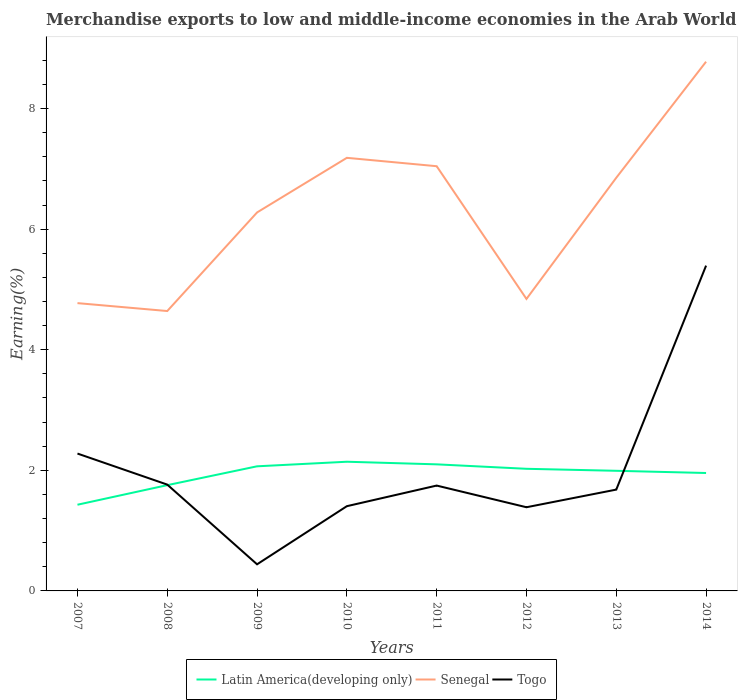Is the number of lines equal to the number of legend labels?
Provide a short and direct response. Yes. Across all years, what is the maximum percentage of amount earned from merchandise exports in Latin America(developing only)?
Offer a very short reply. 1.43. What is the total percentage of amount earned from merchandise exports in Latin America(developing only) in the graph?
Offer a very short reply. -0.39. What is the difference between the highest and the second highest percentage of amount earned from merchandise exports in Senegal?
Make the answer very short. 4.14. Is the percentage of amount earned from merchandise exports in Togo strictly greater than the percentage of amount earned from merchandise exports in Senegal over the years?
Provide a short and direct response. Yes. How many years are there in the graph?
Your answer should be compact. 8. Does the graph contain any zero values?
Your answer should be compact. No. What is the title of the graph?
Make the answer very short. Merchandise exports to low and middle-income economies in the Arab World. What is the label or title of the Y-axis?
Provide a succinct answer. Earning(%). What is the Earning(%) of Latin America(developing only) in 2007?
Offer a terse response. 1.43. What is the Earning(%) of Senegal in 2007?
Your answer should be very brief. 4.77. What is the Earning(%) of Togo in 2007?
Give a very brief answer. 2.28. What is the Earning(%) in Latin America(developing only) in 2008?
Provide a succinct answer. 1.75. What is the Earning(%) of Senegal in 2008?
Ensure brevity in your answer.  4.64. What is the Earning(%) of Togo in 2008?
Provide a succinct answer. 1.76. What is the Earning(%) of Latin America(developing only) in 2009?
Give a very brief answer. 2.07. What is the Earning(%) in Senegal in 2009?
Your response must be concise. 6.28. What is the Earning(%) of Togo in 2009?
Provide a short and direct response. 0.44. What is the Earning(%) in Latin America(developing only) in 2010?
Your response must be concise. 2.14. What is the Earning(%) in Senegal in 2010?
Offer a terse response. 7.18. What is the Earning(%) of Togo in 2010?
Your answer should be compact. 1.41. What is the Earning(%) in Latin America(developing only) in 2011?
Your response must be concise. 2.1. What is the Earning(%) in Senegal in 2011?
Your answer should be compact. 7.04. What is the Earning(%) in Togo in 2011?
Your response must be concise. 1.75. What is the Earning(%) in Latin America(developing only) in 2012?
Your response must be concise. 2.03. What is the Earning(%) of Senegal in 2012?
Your answer should be compact. 4.84. What is the Earning(%) in Togo in 2012?
Your response must be concise. 1.39. What is the Earning(%) of Latin America(developing only) in 2013?
Your answer should be compact. 1.99. What is the Earning(%) in Senegal in 2013?
Provide a succinct answer. 6.85. What is the Earning(%) of Togo in 2013?
Provide a short and direct response. 1.68. What is the Earning(%) in Latin America(developing only) in 2014?
Your response must be concise. 1.96. What is the Earning(%) in Senegal in 2014?
Offer a very short reply. 8.78. What is the Earning(%) of Togo in 2014?
Offer a terse response. 5.4. Across all years, what is the maximum Earning(%) of Latin America(developing only)?
Your response must be concise. 2.14. Across all years, what is the maximum Earning(%) in Senegal?
Your response must be concise. 8.78. Across all years, what is the maximum Earning(%) in Togo?
Your answer should be compact. 5.4. Across all years, what is the minimum Earning(%) of Latin America(developing only)?
Make the answer very short. 1.43. Across all years, what is the minimum Earning(%) in Senegal?
Provide a succinct answer. 4.64. Across all years, what is the minimum Earning(%) in Togo?
Provide a succinct answer. 0.44. What is the total Earning(%) of Latin America(developing only) in the graph?
Your answer should be very brief. 15.47. What is the total Earning(%) of Senegal in the graph?
Offer a terse response. 50.39. What is the total Earning(%) of Togo in the graph?
Make the answer very short. 16.1. What is the difference between the Earning(%) in Latin America(developing only) in 2007 and that in 2008?
Keep it short and to the point. -0.32. What is the difference between the Earning(%) in Senegal in 2007 and that in 2008?
Keep it short and to the point. 0.13. What is the difference between the Earning(%) of Togo in 2007 and that in 2008?
Your response must be concise. 0.51. What is the difference between the Earning(%) in Latin America(developing only) in 2007 and that in 2009?
Make the answer very short. -0.64. What is the difference between the Earning(%) of Senegal in 2007 and that in 2009?
Keep it short and to the point. -1.5. What is the difference between the Earning(%) in Togo in 2007 and that in 2009?
Your response must be concise. 1.84. What is the difference between the Earning(%) in Latin America(developing only) in 2007 and that in 2010?
Provide a succinct answer. -0.71. What is the difference between the Earning(%) of Senegal in 2007 and that in 2010?
Offer a terse response. -2.41. What is the difference between the Earning(%) of Togo in 2007 and that in 2010?
Keep it short and to the point. 0.87. What is the difference between the Earning(%) of Latin America(developing only) in 2007 and that in 2011?
Provide a succinct answer. -0.67. What is the difference between the Earning(%) of Senegal in 2007 and that in 2011?
Keep it short and to the point. -2.27. What is the difference between the Earning(%) of Togo in 2007 and that in 2011?
Your response must be concise. 0.53. What is the difference between the Earning(%) in Latin America(developing only) in 2007 and that in 2012?
Offer a terse response. -0.6. What is the difference between the Earning(%) in Senegal in 2007 and that in 2012?
Keep it short and to the point. -0.07. What is the difference between the Earning(%) of Togo in 2007 and that in 2012?
Provide a short and direct response. 0.89. What is the difference between the Earning(%) in Latin America(developing only) in 2007 and that in 2013?
Give a very brief answer. -0.56. What is the difference between the Earning(%) in Senegal in 2007 and that in 2013?
Your answer should be very brief. -2.08. What is the difference between the Earning(%) in Togo in 2007 and that in 2013?
Your response must be concise. 0.6. What is the difference between the Earning(%) of Latin America(developing only) in 2007 and that in 2014?
Your answer should be very brief. -0.53. What is the difference between the Earning(%) in Senegal in 2007 and that in 2014?
Provide a short and direct response. -4. What is the difference between the Earning(%) of Togo in 2007 and that in 2014?
Your response must be concise. -3.12. What is the difference between the Earning(%) of Latin America(developing only) in 2008 and that in 2009?
Offer a terse response. -0.31. What is the difference between the Earning(%) in Senegal in 2008 and that in 2009?
Ensure brevity in your answer.  -1.64. What is the difference between the Earning(%) of Togo in 2008 and that in 2009?
Your response must be concise. 1.32. What is the difference between the Earning(%) in Latin America(developing only) in 2008 and that in 2010?
Offer a terse response. -0.39. What is the difference between the Earning(%) in Senegal in 2008 and that in 2010?
Make the answer very short. -2.54. What is the difference between the Earning(%) of Togo in 2008 and that in 2010?
Your response must be concise. 0.36. What is the difference between the Earning(%) in Latin America(developing only) in 2008 and that in 2011?
Give a very brief answer. -0.34. What is the difference between the Earning(%) in Senegal in 2008 and that in 2011?
Your answer should be compact. -2.4. What is the difference between the Earning(%) in Togo in 2008 and that in 2011?
Make the answer very short. 0.02. What is the difference between the Earning(%) of Latin America(developing only) in 2008 and that in 2012?
Your answer should be very brief. -0.27. What is the difference between the Earning(%) of Senegal in 2008 and that in 2012?
Make the answer very short. -0.2. What is the difference between the Earning(%) in Togo in 2008 and that in 2012?
Offer a terse response. 0.38. What is the difference between the Earning(%) in Latin America(developing only) in 2008 and that in 2013?
Provide a succinct answer. -0.24. What is the difference between the Earning(%) in Senegal in 2008 and that in 2013?
Offer a very short reply. -2.21. What is the difference between the Earning(%) of Togo in 2008 and that in 2013?
Provide a short and direct response. 0.08. What is the difference between the Earning(%) of Latin America(developing only) in 2008 and that in 2014?
Keep it short and to the point. -0.2. What is the difference between the Earning(%) in Senegal in 2008 and that in 2014?
Provide a short and direct response. -4.14. What is the difference between the Earning(%) in Togo in 2008 and that in 2014?
Offer a very short reply. -3.63. What is the difference between the Earning(%) of Latin America(developing only) in 2009 and that in 2010?
Your answer should be compact. -0.08. What is the difference between the Earning(%) of Senegal in 2009 and that in 2010?
Provide a short and direct response. -0.91. What is the difference between the Earning(%) of Togo in 2009 and that in 2010?
Your answer should be compact. -0.96. What is the difference between the Earning(%) in Latin America(developing only) in 2009 and that in 2011?
Give a very brief answer. -0.03. What is the difference between the Earning(%) of Senegal in 2009 and that in 2011?
Give a very brief answer. -0.77. What is the difference between the Earning(%) of Togo in 2009 and that in 2011?
Offer a very short reply. -1.31. What is the difference between the Earning(%) of Latin America(developing only) in 2009 and that in 2012?
Your answer should be compact. 0.04. What is the difference between the Earning(%) of Senegal in 2009 and that in 2012?
Offer a very short reply. 1.43. What is the difference between the Earning(%) of Togo in 2009 and that in 2012?
Your answer should be compact. -0.95. What is the difference between the Earning(%) of Latin America(developing only) in 2009 and that in 2013?
Your answer should be very brief. 0.07. What is the difference between the Earning(%) of Senegal in 2009 and that in 2013?
Offer a very short reply. -0.58. What is the difference between the Earning(%) in Togo in 2009 and that in 2013?
Offer a terse response. -1.24. What is the difference between the Earning(%) of Latin America(developing only) in 2009 and that in 2014?
Ensure brevity in your answer.  0.11. What is the difference between the Earning(%) of Senegal in 2009 and that in 2014?
Keep it short and to the point. -2.5. What is the difference between the Earning(%) in Togo in 2009 and that in 2014?
Provide a short and direct response. -4.95. What is the difference between the Earning(%) of Latin America(developing only) in 2010 and that in 2011?
Keep it short and to the point. 0.04. What is the difference between the Earning(%) in Senegal in 2010 and that in 2011?
Ensure brevity in your answer.  0.14. What is the difference between the Earning(%) in Togo in 2010 and that in 2011?
Your answer should be very brief. -0.34. What is the difference between the Earning(%) of Latin America(developing only) in 2010 and that in 2012?
Keep it short and to the point. 0.12. What is the difference between the Earning(%) in Senegal in 2010 and that in 2012?
Provide a short and direct response. 2.34. What is the difference between the Earning(%) in Togo in 2010 and that in 2012?
Give a very brief answer. 0.02. What is the difference between the Earning(%) of Latin America(developing only) in 2010 and that in 2013?
Offer a very short reply. 0.15. What is the difference between the Earning(%) in Senegal in 2010 and that in 2013?
Give a very brief answer. 0.33. What is the difference between the Earning(%) of Togo in 2010 and that in 2013?
Keep it short and to the point. -0.27. What is the difference between the Earning(%) of Latin America(developing only) in 2010 and that in 2014?
Ensure brevity in your answer.  0.19. What is the difference between the Earning(%) in Senegal in 2010 and that in 2014?
Provide a short and direct response. -1.59. What is the difference between the Earning(%) in Togo in 2010 and that in 2014?
Keep it short and to the point. -3.99. What is the difference between the Earning(%) in Latin America(developing only) in 2011 and that in 2012?
Your answer should be compact. 0.07. What is the difference between the Earning(%) in Senegal in 2011 and that in 2012?
Provide a succinct answer. 2.2. What is the difference between the Earning(%) in Togo in 2011 and that in 2012?
Ensure brevity in your answer.  0.36. What is the difference between the Earning(%) in Latin America(developing only) in 2011 and that in 2013?
Provide a short and direct response. 0.11. What is the difference between the Earning(%) of Senegal in 2011 and that in 2013?
Your answer should be compact. 0.19. What is the difference between the Earning(%) of Togo in 2011 and that in 2013?
Offer a very short reply. 0.07. What is the difference between the Earning(%) in Latin America(developing only) in 2011 and that in 2014?
Your response must be concise. 0.14. What is the difference between the Earning(%) of Senegal in 2011 and that in 2014?
Offer a very short reply. -1.73. What is the difference between the Earning(%) of Togo in 2011 and that in 2014?
Keep it short and to the point. -3.65. What is the difference between the Earning(%) in Latin America(developing only) in 2012 and that in 2013?
Your response must be concise. 0.03. What is the difference between the Earning(%) in Senegal in 2012 and that in 2013?
Your response must be concise. -2.01. What is the difference between the Earning(%) in Togo in 2012 and that in 2013?
Offer a very short reply. -0.29. What is the difference between the Earning(%) in Latin America(developing only) in 2012 and that in 2014?
Provide a succinct answer. 0.07. What is the difference between the Earning(%) of Senegal in 2012 and that in 2014?
Your answer should be compact. -3.93. What is the difference between the Earning(%) in Togo in 2012 and that in 2014?
Offer a terse response. -4.01. What is the difference between the Earning(%) in Latin America(developing only) in 2013 and that in 2014?
Provide a succinct answer. 0.04. What is the difference between the Earning(%) in Senegal in 2013 and that in 2014?
Ensure brevity in your answer.  -1.92. What is the difference between the Earning(%) of Togo in 2013 and that in 2014?
Offer a terse response. -3.71. What is the difference between the Earning(%) in Latin America(developing only) in 2007 and the Earning(%) in Senegal in 2008?
Offer a very short reply. -3.21. What is the difference between the Earning(%) of Latin America(developing only) in 2007 and the Earning(%) of Togo in 2008?
Keep it short and to the point. -0.33. What is the difference between the Earning(%) of Senegal in 2007 and the Earning(%) of Togo in 2008?
Offer a very short reply. 3.01. What is the difference between the Earning(%) in Latin America(developing only) in 2007 and the Earning(%) in Senegal in 2009?
Your answer should be compact. -4.85. What is the difference between the Earning(%) of Latin America(developing only) in 2007 and the Earning(%) of Togo in 2009?
Your answer should be compact. 0.99. What is the difference between the Earning(%) in Senegal in 2007 and the Earning(%) in Togo in 2009?
Ensure brevity in your answer.  4.33. What is the difference between the Earning(%) of Latin America(developing only) in 2007 and the Earning(%) of Senegal in 2010?
Provide a short and direct response. -5.75. What is the difference between the Earning(%) of Latin America(developing only) in 2007 and the Earning(%) of Togo in 2010?
Offer a very short reply. 0.02. What is the difference between the Earning(%) in Senegal in 2007 and the Earning(%) in Togo in 2010?
Your response must be concise. 3.37. What is the difference between the Earning(%) in Latin America(developing only) in 2007 and the Earning(%) in Senegal in 2011?
Offer a terse response. -5.61. What is the difference between the Earning(%) in Latin America(developing only) in 2007 and the Earning(%) in Togo in 2011?
Your answer should be compact. -0.32. What is the difference between the Earning(%) in Senegal in 2007 and the Earning(%) in Togo in 2011?
Your answer should be compact. 3.03. What is the difference between the Earning(%) in Latin America(developing only) in 2007 and the Earning(%) in Senegal in 2012?
Offer a very short reply. -3.41. What is the difference between the Earning(%) in Latin America(developing only) in 2007 and the Earning(%) in Togo in 2012?
Offer a very short reply. 0.04. What is the difference between the Earning(%) in Senegal in 2007 and the Earning(%) in Togo in 2012?
Offer a terse response. 3.39. What is the difference between the Earning(%) of Latin America(developing only) in 2007 and the Earning(%) of Senegal in 2013?
Give a very brief answer. -5.42. What is the difference between the Earning(%) in Latin America(developing only) in 2007 and the Earning(%) in Togo in 2013?
Offer a very short reply. -0.25. What is the difference between the Earning(%) of Senegal in 2007 and the Earning(%) of Togo in 2013?
Ensure brevity in your answer.  3.09. What is the difference between the Earning(%) of Latin America(developing only) in 2007 and the Earning(%) of Senegal in 2014?
Ensure brevity in your answer.  -7.35. What is the difference between the Earning(%) in Latin America(developing only) in 2007 and the Earning(%) in Togo in 2014?
Give a very brief answer. -3.97. What is the difference between the Earning(%) in Senegal in 2007 and the Earning(%) in Togo in 2014?
Make the answer very short. -0.62. What is the difference between the Earning(%) in Latin America(developing only) in 2008 and the Earning(%) in Senegal in 2009?
Offer a terse response. -4.52. What is the difference between the Earning(%) in Latin America(developing only) in 2008 and the Earning(%) in Togo in 2009?
Your response must be concise. 1.31. What is the difference between the Earning(%) of Senegal in 2008 and the Earning(%) of Togo in 2009?
Keep it short and to the point. 4.2. What is the difference between the Earning(%) in Latin America(developing only) in 2008 and the Earning(%) in Senegal in 2010?
Your answer should be very brief. -5.43. What is the difference between the Earning(%) of Latin America(developing only) in 2008 and the Earning(%) of Togo in 2010?
Your response must be concise. 0.35. What is the difference between the Earning(%) of Senegal in 2008 and the Earning(%) of Togo in 2010?
Your answer should be compact. 3.24. What is the difference between the Earning(%) in Latin America(developing only) in 2008 and the Earning(%) in Senegal in 2011?
Your answer should be compact. -5.29. What is the difference between the Earning(%) of Latin America(developing only) in 2008 and the Earning(%) of Togo in 2011?
Provide a short and direct response. 0.01. What is the difference between the Earning(%) in Senegal in 2008 and the Earning(%) in Togo in 2011?
Your answer should be compact. 2.89. What is the difference between the Earning(%) of Latin America(developing only) in 2008 and the Earning(%) of Senegal in 2012?
Your answer should be very brief. -3.09. What is the difference between the Earning(%) in Latin America(developing only) in 2008 and the Earning(%) in Togo in 2012?
Offer a terse response. 0.37. What is the difference between the Earning(%) in Senegal in 2008 and the Earning(%) in Togo in 2012?
Ensure brevity in your answer.  3.25. What is the difference between the Earning(%) of Latin America(developing only) in 2008 and the Earning(%) of Senegal in 2013?
Provide a succinct answer. -5.1. What is the difference between the Earning(%) of Latin America(developing only) in 2008 and the Earning(%) of Togo in 2013?
Your answer should be very brief. 0.07. What is the difference between the Earning(%) in Senegal in 2008 and the Earning(%) in Togo in 2013?
Your answer should be compact. 2.96. What is the difference between the Earning(%) of Latin America(developing only) in 2008 and the Earning(%) of Senegal in 2014?
Offer a very short reply. -7.02. What is the difference between the Earning(%) in Latin America(developing only) in 2008 and the Earning(%) in Togo in 2014?
Offer a very short reply. -3.64. What is the difference between the Earning(%) of Senegal in 2008 and the Earning(%) of Togo in 2014?
Provide a succinct answer. -0.75. What is the difference between the Earning(%) of Latin America(developing only) in 2009 and the Earning(%) of Senegal in 2010?
Your answer should be compact. -5.12. What is the difference between the Earning(%) in Latin America(developing only) in 2009 and the Earning(%) in Togo in 2010?
Your answer should be very brief. 0.66. What is the difference between the Earning(%) in Senegal in 2009 and the Earning(%) in Togo in 2010?
Give a very brief answer. 4.87. What is the difference between the Earning(%) in Latin America(developing only) in 2009 and the Earning(%) in Senegal in 2011?
Provide a short and direct response. -4.98. What is the difference between the Earning(%) in Latin America(developing only) in 2009 and the Earning(%) in Togo in 2011?
Provide a succinct answer. 0.32. What is the difference between the Earning(%) of Senegal in 2009 and the Earning(%) of Togo in 2011?
Your answer should be very brief. 4.53. What is the difference between the Earning(%) in Latin America(developing only) in 2009 and the Earning(%) in Senegal in 2012?
Provide a succinct answer. -2.78. What is the difference between the Earning(%) in Latin America(developing only) in 2009 and the Earning(%) in Togo in 2012?
Give a very brief answer. 0.68. What is the difference between the Earning(%) of Senegal in 2009 and the Earning(%) of Togo in 2012?
Your answer should be compact. 4.89. What is the difference between the Earning(%) of Latin America(developing only) in 2009 and the Earning(%) of Senegal in 2013?
Make the answer very short. -4.79. What is the difference between the Earning(%) in Latin America(developing only) in 2009 and the Earning(%) in Togo in 2013?
Give a very brief answer. 0.39. What is the difference between the Earning(%) of Senegal in 2009 and the Earning(%) of Togo in 2013?
Your answer should be very brief. 4.6. What is the difference between the Earning(%) in Latin America(developing only) in 2009 and the Earning(%) in Senegal in 2014?
Your response must be concise. -6.71. What is the difference between the Earning(%) of Latin America(developing only) in 2009 and the Earning(%) of Togo in 2014?
Ensure brevity in your answer.  -3.33. What is the difference between the Earning(%) of Senegal in 2009 and the Earning(%) of Togo in 2014?
Provide a succinct answer. 0.88. What is the difference between the Earning(%) in Latin America(developing only) in 2010 and the Earning(%) in Senegal in 2011?
Offer a terse response. -4.9. What is the difference between the Earning(%) in Latin America(developing only) in 2010 and the Earning(%) in Togo in 2011?
Provide a short and direct response. 0.4. What is the difference between the Earning(%) in Senegal in 2010 and the Earning(%) in Togo in 2011?
Your answer should be compact. 5.44. What is the difference between the Earning(%) in Latin America(developing only) in 2010 and the Earning(%) in Senegal in 2012?
Offer a very short reply. -2.7. What is the difference between the Earning(%) of Latin America(developing only) in 2010 and the Earning(%) of Togo in 2012?
Offer a very short reply. 0.75. What is the difference between the Earning(%) of Senegal in 2010 and the Earning(%) of Togo in 2012?
Keep it short and to the point. 5.8. What is the difference between the Earning(%) of Latin America(developing only) in 2010 and the Earning(%) of Senegal in 2013?
Provide a succinct answer. -4.71. What is the difference between the Earning(%) in Latin America(developing only) in 2010 and the Earning(%) in Togo in 2013?
Give a very brief answer. 0.46. What is the difference between the Earning(%) of Senegal in 2010 and the Earning(%) of Togo in 2013?
Your answer should be compact. 5.5. What is the difference between the Earning(%) in Latin America(developing only) in 2010 and the Earning(%) in Senegal in 2014?
Offer a terse response. -6.63. What is the difference between the Earning(%) in Latin America(developing only) in 2010 and the Earning(%) in Togo in 2014?
Your answer should be very brief. -3.25. What is the difference between the Earning(%) in Senegal in 2010 and the Earning(%) in Togo in 2014?
Give a very brief answer. 1.79. What is the difference between the Earning(%) in Latin America(developing only) in 2011 and the Earning(%) in Senegal in 2012?
Your answer should be very brief. -2.74. What is the difference between the Earning(%) in Latin America(developing only) in 2011 and the Earning(%) in Togo in 2012?
Your response must be concise. 0.71. What is the difference between the Earning(%) of Senegal in 2011 and the Earning(%) of Togo in 2012?
Your response must be concise. 5.66. What is the difference between the Earning(%) in Latin America(developing only) in 2011 and the Earning(%) in Senegal in 2013?
Make the answer very short. -4.75. What is the difference between the Earning(%) in Latin America(developing only) in 2011 and the Earning(%) in Togo in 2013?
Ensure brevity in your answer.  0.42. What is the difference between the Earning(%) of Senegal in 2011 and the Earning(%) of Togo in 2013?
Your answer should be compact. 5.36. What is the difference between the Earning(%) in Latin America(developing only) in 2011 and the Earning(%) in Senegal in 2014?
Your response must be concise. -6.68. What is the difference between the Earning(%) in Latin America(developing only) in 2011 and the Earning(%) in Togo in 2014?
Provide a short and direct response. -3.3. What is the difference between the Earning(%) in Senegal in 2011 and the Earning(%) in Togo in 2014?
Offer a very short reply. 1.65. What is the difference between the Earning(%) of Latin America(developing only) in 2012 and the Earning(%) of Senegal in 2013?
Offer a terse response. -4.83. What is the difference between the Earning(%) of Latin America(developing only) in 2012 and the Earning(%) of Togo in 2013?
Offer a very short reply. 0.34. What is the difference between the Earning(%) of Senegal in 2012 and the Earning(%) of Togo in 2013?
Provide a succinct answer. 3.16. What is the difference between the Earning(%) in Latin America(developing only) in 2012 and the Earning(%) in Senegal in 2014?
Provide a succinct answer. -6.75. What is the difference between the Earning(%) in Latin America(developing only) in 2012 and the Earning(%) in Togo in 2014?
Keep it short and to the point. -3.37. What is the difference between the Earning(%) in Senegal in 2012 and the Earning(%) in Togo in 2014?
Make the answer very short. -0.55. What is the difference between the Earning(%) of Latin America(developing only) in 2013 and the Earning(%) of Senegal in 2014?
Your answer should be very brief. -6.79. What is the difference between the Earning(%) in Latin America(developing only) in 2013 and the Earning(%) in Togo in 2014?
Your answer should be compact. -3.4. What is the difference between the Earning(%) in Senegal in 2013 and the Earning(%) in Togo in 2014?
Your answer should be very brief. 1.46. What is the average Earning(%) of Latin America(developing only) per year?
Your response must be concise. 1.93. What is the average Earning(%) in Senegal per year?
Provide a succinct answer. 6.3. What is the average Earning(%) of Togo per year?
Your response must be concise. 2.01. In the year 2007, what is the difference between the Earning(%) of Latin America(developing only) and Earning(%) of Senegal?
Offer a very short reply. -3.34. In the year 2007, what is the difference between the Earning(%) of Latin America(developing only) and Earning(%) of Togo?
Your answer should be compact. -0.85. In the year 2007, what is the difference between the Earning(%) of Senegal and Earning(%) of Togo?
Give a very brief answer. 2.5. In the year 2008, what is the difference between the Earning(%) of Latin America(developing only) and Earning(%) of Senegal?
Your response must be concise. -2.89. In the year 2008, what is the difference between the Earning(%) of Latin America(developing only) and Earning(%) of Togo?
Keep it short and to the point. -0.01. In the year 2008, what is the difference between the Earning(%) in Senegal and Earning(%) in Togo?
Make the answer very short. 2.88. In the year 2009, what is the difference between the Earning(%) in Latin America(developing only) and Earning(%) in Senegal?
Offer a very short reply. -4.21. In the year 2009, what is the difference between the Earning(%) in Latin America(developing only) and Earning(%) in Togo?
Provide a succinct answer. 1.63. In the year 2009, what is the difference between the Earning(%) in Senegal and Earning(%) in Togo?
Give a very brief answer. 5.84. In the year 2010, what is the difference between the Earning(%) of Latin America(developing only) and Earning(%) of Senegal?
Your response must be concise. -5.04. In the year 2010, what is the difference between the Earning(%) in Latin America(developing only) and Earning(%) in Togo?
Provide a succinct answer. 0.74. In the year 2010, what is the difference between the Earning(%) of Senegal and Earning(%) of Togo?
Your answer should be compact. 5.78. In the year 2011, what is the difference between the Earning(%) of Latin America(developing only) and Earning(%) of Senegal?
Ensure brevity in your answer.  -4.94. In the year 2011, what is the difference between the Earning(%) in Latin America(developing only) and Earning(%) in Togo?
Offer a terse response. 0.35. In the year 2011, what is the difference between the Earning(%) in Senegal and Earning(%) in Togo?
Provide a short and direct response. 5.3. In the year 2012, what is the difference between the Earning(%) of Latin America(developing only) and Earning(%) of Senegal?
Keep it short and to the point. -2.82. In the year 2012, what is the difference between the Earning(%) of Latin America(developing only) and Earning(%) of Togo?
Offer a very short reply. 0.64. In the year 2012, what is the difference between the Earning(%) in Senegal and Earning(%) in Togo?
Give a very brief answer. 3.46. In the year 2013, what is the difference between the Earning(%) of Latin America(developing only) and Earning(%) of Senegal?
Your answer should be very brief. -4.86. In the year 2013, what is the difference between the Earning(%) of Latin America(developing only) and Earning(%) of Togo?
Make the answer very short. 0.31. In the year 2013, what is the difference between the Earning(%) in Senegal and Earning(%) in Togo?
Ensure brevity in your answer.  5.17. In the year 2014, what is the difference between the Earning(%) of Latin America(developing only) and Earning(%) of Senegal?
Provide a succinct answer. -6.82. In the year 2014, what is the difference between the Earning(%) of Latin America(developing only) and Earning(%) of Togo?
Ensure brevity in your answer.  -3.44. In the year 2014, what is the difference between the Earning(%) in Senegal and Earning(%) in Togo?
Provide a short and direct response. 3.38. What is the ratio of the Earning(%) of Latin America(developing only) in 2007 to that in 2008?
Make the answer very short. 0.81. What is the ratio of the Earning(%) in Senegal in 2007 to that in 2008?
Your answer should be very brief. 1.03. What is the ratio of the Earning(%) of Togo in 2007 to that in 2008?
Your answer should be compact. 1.29. What is the ratio of the Earning(%) of Latin America(developing only) in 2007 to that in 2009?
Ensure brevity in your answer.  0.69. What is the ratio of the Earning(%) of Senegal in 2007 to that in 2009?
Provide a succinct answer. 0.76. What is the ratio of the Earning(%) in Togo in 2007 to that in 2009?
Ensure brevity in your answer.  5.16. What is the ratio of the Earning(%) of Latin America(developing only) in 2007 to that in 2010?
Your response must be concise. 0.67. What is the ratio of the Earning(%) in Senegal in 2007 to that in 2010?
Your answer should be compact. 0.66. What is the ratio of the Earning(%) of Togo in 2007 to that in 2010?
Keep it short and to the point. 1.62. What is the ratio of the Earning(%) in Latin America(developing only) in 2007 to that in 2011?
Make the answer very short. 0.68. What is the ratio of the Earning(%) in Senegal in 2007 to that in 2011?
Provide a succinct answer. 0.68. What is the ratio of the Earning(%) in Togo in 2007 to that in 2011?
Keep it short and to the point. 1.3. What is the ratio of the Earning(%) of Latin America(developing only) in 2007 to that in 2012?
Make the answer very short. 0.71. What is the ratio of the Earning(%) of Senegal in 2007 to that in 2012?
Make the answer very short. 0.99. What is the ratio of the Earning(%) in Togo in 2007 to that in 2012?
Your answer should be very brief. 1.64. What is the ratio of the Earning(%) in Latin America(developing only) in 2007 to that in 2013?
Provide a succinct answer. 0.72. What is the ratio of the Earning(%) of Senegal in 2007 to that in 2013?
Provide a short and direct response. 0.7. What is the ratio of the Earning(%) in Togo in 2007 to that in 2013?
Make the answer very short. 1.36. What is the ratio of the Earning(%) of Latin America(developing only) in 2007 to that in 2014?
Your answer should be very brief. 0.73. What is the ratio of the Earning(%) of Senegal in 2007 to that in 2014?
Ensure brevity in your answer.  0.54. What is the ratio of the Earning(%) of Togo in 2007 to that in 2014?
Ensure brevity in your answer.  0.42. What is the ratio of the Earning(%) of Latin America(developing only) in 2008 to that in 2009?
Your answer should be compact. 0.85. What is the ratio of the Earning(%) of Senegal in 2008 to that in 2009?
Offer a very short reply. 0.74. What is the ratio of the Earning(%) of Togo in 2008 to that in 2009?
Your answer should be compact. 4. What is the ratio of the Earning(%) in Latin America(developing only) in 2008 to that in 2010?
Ensure brevity in your answer.  0.82. What is the ratio of the Earning(%) of Senegal in 2008 to that in 2010?
Make the answer very short. 0.65. What is the ratio of the Earning(%) in Togo in 2008 to that in 2010?
Make the answer very short. 1.25. What is the ratio of the Earning(%) in Latin America(developing only) in 2008 to that in 2011?
Offer a terse response. 0.84. What is the ratio of the Earning(%) in Senegal in 2008 to that in 2011?
Offer a very short reply. 0.66. What is the ratio of the Earning(%) in Togo in 2008 to that in 2011?
Offer a terse response. 1.01. What is the ratio of the Earning(%) in Latin America(developing only) in 2008 to that in 2012?
Offer a very short reply. 0.87. What is the ratio of the Earning(%) of Senegal in 2008 to that in 2012?
Ensure brevity in your answer.  0.96. What is the ratio of the Earning(%) of Togo in 2008 to that in 2012?
Make the answer very short. 1.27. What is the ratio of the Earning(%) of Latin America(developing only) in 2008 to that in 2013?
Your answer should be compact. 0.88. What is the ratio of the Earning(%) of Senegal in 2008 to that in 2013?
Give a very brief answer. 0.68. What is the ratio of the Earning(%) of Togo in 2008 to that in 2013?
Provide a succinct answer. 1.05. What is the ratio of the Earning(%) in Latin America(developing only) in 2008 to that in 2014?
Your answer should be very brief. 0.9. What is the ratio of the Earning(%) in Senegal in 2008 to that in 2014?
Offer a terse response. 0.53. What is the ratio of the Earning(%) in Togo in 2008 to that in 2014?
Provide a succinct answer. 0.33. What is the ratio of the Earning(%) in Latin America(developing only) in 2009 to that in 2010?
Provide a short and direct response. 0.96. What is the ratio of the Earning(%) of Senegal in 2009 to that in 2010?
Your answer should be compact. 0.87. What is the ratio of the Earning(%) of Togo in 2009 to that in 2010?
Provide a succinct answer. 0.31. What is the ratio of the Earning(%) of Latin America(developing only) in 2009 to that in 2011?
Keep it short and to the point. 0.98. What is the ratio of the Earning(%) of Senegal in 2009 to that in 2011?
Ensure brevity in your answer.  0.89. What is the ratio of the Earning(%) of Togo in 2009 to that in 2011?
Give a very brief answer. 0.25. What is the ratio of the Earning(%) in Latin America(developing only) in 2009 to that in 2012?
Ensure brevity in your answer.  1.02. What is the ratio of the Earning(%) of Senegal in 2009 to that in 2012?
Give a very brief answer. 1.3. What is the ratio of the Earning(%) in Togo in 2009 to that in 2012?
Ensure brevity in your answer.  0.32. What is the ratio of the Earning(%) in Latin America(developing only) in 2009 to that in 2013?
Give a very brief answer. 1.04. What is the ratio of the Earning(%) in Senegal in 2009 to that in 2013?
Give a very brief answer. 0.92. What is the ratio of the Earning(%) in Togo in 2009 to that in 2013?
Your answer should be very brief. 0.26. What is the ratio of the Earning(%) of Latin America(developing only) in 2009 to that in 2014?
Provide a short and direct response. 1.06. What is the ratio of the Earning(%) in Senegal in 2009 to that in 2014?
Keep it short and to the point. 0.72. What is the ratio of the Earning(%) of Togo in 2009 to that in 2014?
Offer a terse response. 0.08. What is the ratio of the Earning(%) of Latin America(developing only) in 2010 to that in 2011?
Keep it short and to the point. 1.02. What is the ratio of the Earning(%) of Senegal in 2010 to that in 2011?
Your answer should be very brief. 1.02. What is the ratio of the Earning(%) in Togo in 2010 to that in 2011?
Ensure brevity in your answer.  0.8. What is the ratio of the Earning(%) of Latin America(developing only) in 2010 to that in 2012?
Give a very brief answer. 1.06. What is the ratio of the Earning(%) in Senegal in 2010 to that in 2012?
Ensure brevity in your answer.  1.48. What is the ratio of the Earning(%) of Togo in 2010 to that in 2012?
Your answer should be compact. 1.01. What is the ratio of the Earning(%) of Latin America(developing only) in 2010 to that in 2013?
Your answer should be compact. 1.08. What is the ratio of the Earning(%) in Senegal in 2010 to that in 2013?
Your response must be concise. 1.05. What is the ratio of the Earning(%) of Togo in 2010 to that in 2013?
Give a very brief answer. 0.84. What is the ratio of the Earning(%) of Latin America(developing only) in 2010 to that in 2014?
Keep it short and to the point. 1.1. What is the ratio of the Earning(%) in Senegal in 2010 to that in 2014?
Provide a succinct answer. 0.82. What is the ratio of the Earning(%) of Togo in 2010 to that in 2014?
Your response must be concise. 0.26. What is the ratio of the Earning(%) in Latin America(developing only) in 2011 to that in 2012?
Your response must be concise. 1.04. What is the ratio of the Earning(%) of Senegal in 2011 to that in 2012?
Offer a very short reply. 1.45. What is the ratio of the Earning(%) in Togo in 2011 to that in 2012?
Provide a succinct answer. 1.26. What is the ratio of the Earning(%) in Latin America(developing only) in 2011 to that in 2013?
Your answer should be compact. 1.05. What is the ratio of the Earning(%) of Senegal in 2011 to that in 2013?
Your answer should be very brief. 1.03. What is the ratio of the Earning(%) of Togo in 2011 to that in 2013?
Give a very brief answer. 1.04. What is the ratio of the Earning(%) of Latin America(developing only) in 2011 to that in 2014?
Give a very brief answer. 1.07. What is the ratio of the Earning(%) in Senegal in 2011 to that in 2014?
Your response must be concise. 0.8. What is the ratio of the Earning(%) in Togo in 2011 to that in 2014?
Offer a terse response. 0.32. What is the ratio of the Earning(%) in Latin America(developing only) in 2012 to that in 2013?
Keep it short and to the point. 1.02. What is the ratio of the Earning(%) in Senegal in 2012 to that in 2013?
Make the answer very short. 0.71. What is the ratio of the Earning(%) of Togo in 2012 to that in 2013?
Provide a short and direct response. 0.83. What is the ratio of the Earning(%) in Latin America(developing only) in 2012 to that in 2014?
Your answer should be compact. 1.04. What is the ratio of the Earning(%) of Senegal in 2012 to that in 2014?
Offer a terse response. 0.55. What is the ratio of the Earning(%) in Togo in 2012 to that in 2014?
Offer a terse response. 0.26. What is the ratio of the Earning(%) in Latin America(developing only) in 2013 to that in 2014?
Provide a short and direct response. 1.02. What is the ratio of the Earning(%) in Senegal in 2013 to that in 2014?
Keep it short and to the point. 0.78. What is the ratio of the Earning(%) of Togo in 2013 to that in 2014?
Offer a very short reply. 0.31. What is the difference between the highest and the second highest Earning(%) in Latin America(developing only)?
Offer a terse response. 0.04. What is the difference between the highest and the second highest Earning(%) of Senegal?
Your answer should be very brief. 1.59. What is the difference between the highest and the second highest Earning(%) of Togo?
Your answer should be very brief. 3.12. What is the difference between the highest and the lowest Earning(%) of Latin America(developing only)?
Provide a succinct answer. 0.71. What is the difference between the highest and the lowest Earning(%) of Senegal?
Provide a succinct answer. 4.14. What is the difference between the highest and the lowest Earning(%) of Togo?
Offer a terse response. 4.95. 